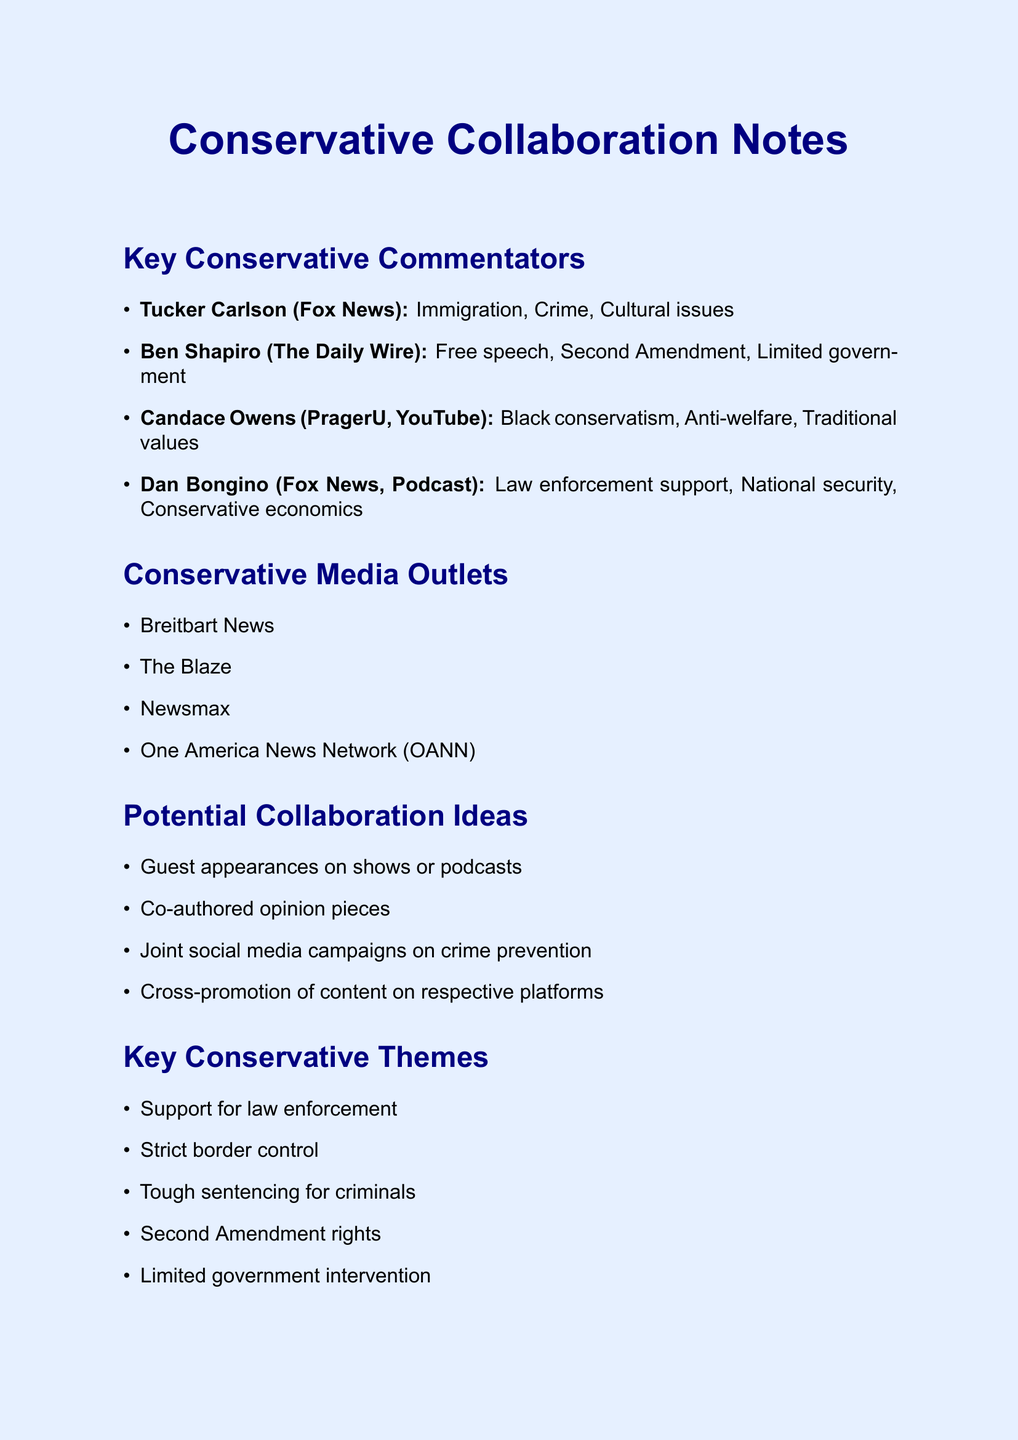What is the name of the commentator associated with Fox News? The document lists Tucker Carlson as the commentator associated with Fox News.
Answer: Tucker Carlson Which platform is Ben Shapiro associated with? The document states that Ben Shapiro is associated with The Daily Wire.
Answer: The Daily Wire What key topic does Candace Owens focus on? The document mentions that Candace Owens focuses on Black conservatism.
Answer: Black conservatism How many potential collaboration ideas are listed? The document contains a total of four potential collaboration ideas.
Answer: 4 What is one of the key conservative themes mentioned? The document provides a list of key conservative themes, including support for law enforcement.
Answer: Support for law enforcement What type of media outlet is Breitbart News? The document categorizes Breitbart News as a conservative media outlet.
Answer: Conservative media outlet Which social media hashtag is suggested for use? The document suggests using the hashtag #BackTheBlue.
Answer: #BackTheBlue What collaboration idea involves content sharing? The document lists cross-promotion of content on respective platforms as an idea.
Answer: Cross-promotion of content on respective platforms 